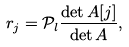Convert formula to latex. <formula><loc_0><loc_0><loc_500><loc_500>r _ { j } = { \mathcal { P } _ { l } } \frac { \det A [ j ] } { \det A } ,</formula> 